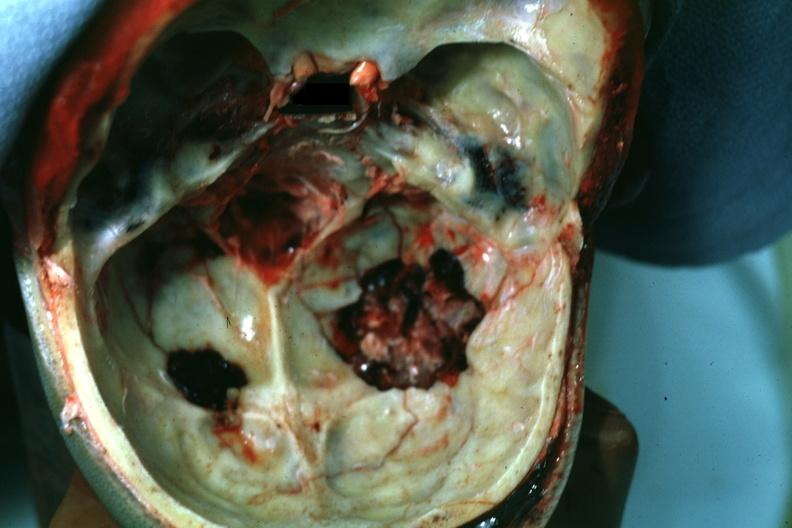does wound look more like a gunshot wound?
Answer the question using a single word or phrase. No 